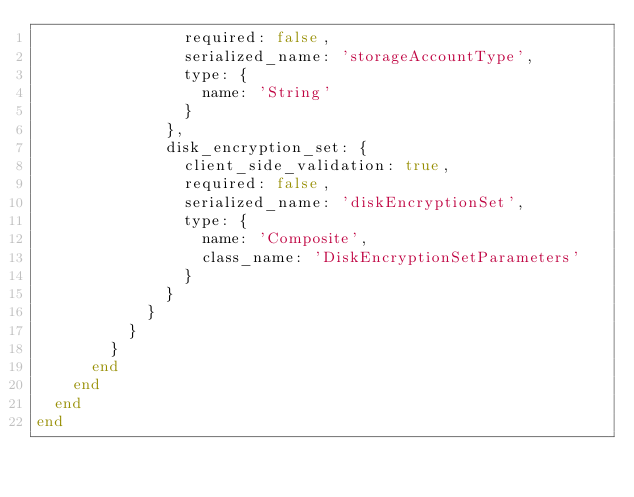<code> <loc_0><loc_0><loc_500><loc_500><_Ruby_>                required: false,
                serialized_name: 'storageAccountType',
                type: {
                  name: 'String'
                }
              },
              disk_encryption_set: {
                client_side_validation: true,
                required: false,
                serialized_name: 'diskEncryptionSet',
                type: {
                  name: 'Composite',
                  class_name: 'DiskEncryptionSetParameters'
                }
              }
            }
          }
        }
      end
    end
  end
end
</code> 